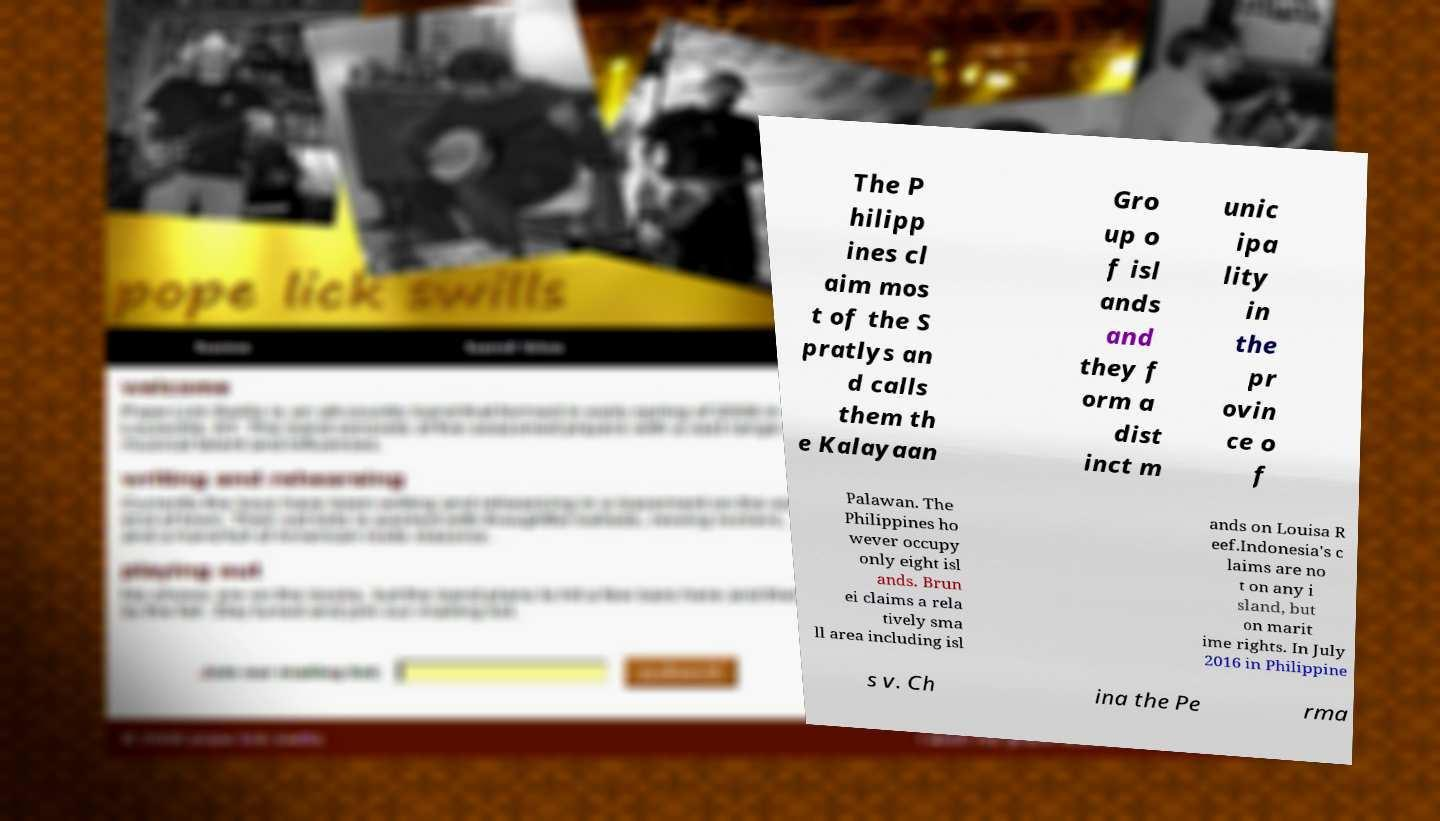Can you read and provide the text displayed in the image?This photo seems to have some interesting text. Can you extract and type it out for me? The P hilipp ines cl aim mos t of the S pratlys an d calls them th e Kalayaan Gro up o f isl ands and they f orm a dist inct m unic ipa lity in the pr ovin ce o f Palawan. The Philippines ho wever occupy only eight isl ands. Brun ei claims a rela tively sma ll area including isl ands on Louisa R eef.Indonesia's c laims are no t on any i sland, but on marit ime rights. In July 2016 in Philippine s v. Ch ina the Pe rma 